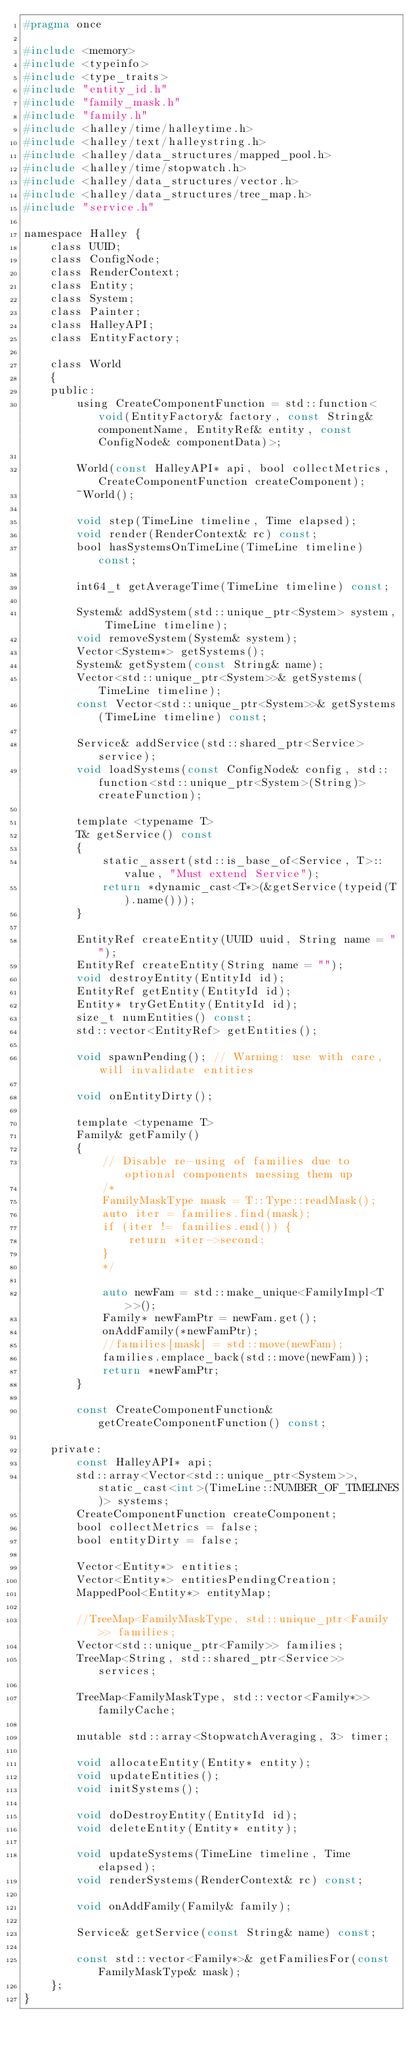<code> <loc_0><loc_0><loc_500><loc_500><_C_>#pragma once

#include <memory>
#include <typeinfo>
#include <type_traits>
#include "entity_id.h"
#include "family_mask.h"
#include "family.h"
#include <halley/time/halleytime.h>
#include <halley/text/halleystring.h>
#include <halley/data_structures/mapped_pool.h>
#include <halley/time/stopwatch.h>
#include <halley/data_structures/vector.h>
#include <halley/data_structures/tree_map.h>
#include "service.h"

namespace Halley {
	class UUID;
	class ConfigNode;
	class RenderContext;
	class Entity;
	class System;
	class Painter;
	class HalleyAPI;
	class EntityFactory;

	class World
	{
	public:
		using CreateComponentFunction = std::function<void(EntityFactory& factory, const String& componentName, EntityRef& entity, const ConfigNode& componentData)>;

		World(const HalleyAPI* api, bool collectMetrics, CreateComponentFunction createComponent);
		~World();

		void step(TimeLine timeline, Time elapsed);
		void render(RenderContext& rc) const;
		bool hasSystemsOnTimeLine(TimeLine timeline) const;
		
		int64_t getAverageTime(TimeLine timeline) const;

		System& addSystem(std::unique_ptr<System> system, TimeLine timeline);
		void removeSystem(System& system);
		Vector<System*> getSystems();
		System& getSystem(const String& name);
		Vector<std::unique_ptr<System>>& getSystems(TimeLine timeline);
		const Vector<std::unique_ptr<System>>& getSystems(TimeLine timeline) const;

		Service& addService(std::shared_ptr<Service> service);
		void loadSystems(const ConfigNode& config, std::function<std::unique_ptr<System>(String)> createFunction);

		template <typename T>
		T& getService() const
		{
			static_assert(std::is_base_of<Service, T>::value, "Must extend Service");
			return *dynamic_cast<T*>(&getService(typeid(T).name()));
		}

		EntityRef createEntity(UUID uuid, String name = "");
		EntityRef createEntity(String name = "");
		void destroyEntity(EntityId id);
		EntityRef getEntity(EntityId id);
		Entity* tryGetEntity(EntityId id);
		size_t numEntities() const;
		std::vector<EntityRef> getEntities();

		void spawnPending(); // Warning: use with care, will invalidate entities

		void onEntityDirty();

		template <typename T>
		Family& getFamily()
		{
			// Disable re-using of families due to optional components messing them up
			/*
			FamilyMaskType mask = T::Type::readMask();
			auto iter = families.find(mask);
			if (iter != families.end()) {
				return *iter->second;
			}
			*/

			auto newFam = std::make_unique<FamilyImpl<T>>();
			Family* newFamPtr = newFam.get();
			onAddFamily(*newFamPtr);
			//families[mask] = std::move(newFam);
			families.emplace_back(std::move(newFam));
			return *newFamPtr;
		}

		const CreateComponentFunction& getCreateComponentFunction() const;

	private:
		const HalleyAPI* api;
		std::array<Vector<std::unique_ptr<System>>, static_cast<int>(TimeLine::NUMBER_OF_TIMELINES)> systems;
		CreateComponentFunction createComponent;
		bool collectMetrics = false;
		bool entityDirty = false;
		
		Vector<Entity*> entities;
		Vector<Entity*> entitiesPendingCreation;
		MappedPool<Entity*> entityMap;

		//TreeMap<FamilyMaskType, std::unique_ptr<Family>> families;
		Vector<std::unique_ptr<Family>> families;
		TreeMap<String, std::shared_ptr<Service>> services;

		TreeMap<FamilyMaskType, std::vector<Family*>> familyCache;

		mutable std::array<StopwatchAveraging, 3> timer;

		void allocateEntity(Entity* entity);
		void updateEntities();
		void initSystems();

		void doDestroyEntity(EntityId id);
		void deleteEntity(Entity* entity);

		void updateSystems(TimeLine timeline, Time elapsed);
		void renderSystems(RenderContext& rc) const;
		
		void onAddFamily(Family& family);

		Service& getService(const String& name) const;

		const std::vector<Family*>& getFamiliesFor(const FamilyMaskType& mask);
	};
}
</code> 